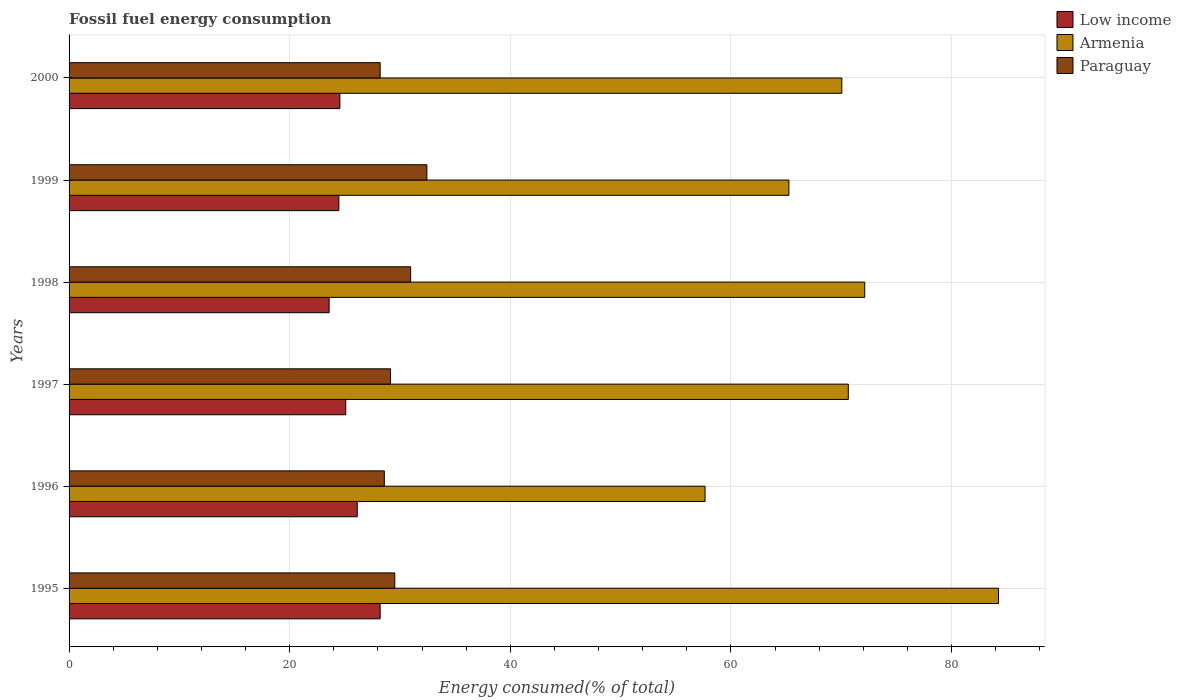How many different coloured bars are there?
Keep it short and to the point. 3. How many groups of bars are there?
Make the answer very short. 6. Are the number of bars per tick equal to the number of legend labels?
Offer a terse response. Yes. Are the number of bars on each tick of the Y-axis equal?
Make the answer very short. Yes. How many bars are there on the 1st tick from the top?
Your answer should be very brief. 3. What is the percentage of energy consumed in Low income in 1996?
Make the answer very short. 26.12. Across all years, what is the maximum percentage of energy consumed in Armenia?
Provide a succinct answer. 84.25. Across all years, what is the minimum percentage of energy consumed in Paraguay?
Your answer should be very brief. 28.2. In which year was the percentage of energy consumed in Low income maximum?
Give a very brief answer. 1995. What is the total percentage of energy consumed in Paraguay in the graph?
Provide a short and direct response. 178.84. What is the difference between the percentage of energy consumed in Armenia in 1995 and that in 2000?
Make the answer very short. 14.2. What is the difference between the percentage of energy consumed in Paraguay in 2000 and the percentage of energy consumed in Low income in 1997?
Give a very brief answer. 3.12. What is the average percentage of energy consumed in Paraguay per year?
Offer a terse response. 29.81. In the year 1999, what is the difference between the percentage of energy consumed in Low income and percentage of energy consumed in Paraguay?
Your answer should be compact. -7.98. In how many years, is the percentage of energy consumed in Low income greater than 4 %?
Provide a short and direct response. 6. What is the ratio of the percentage of energy consumed in Paraguay in 1998 to that in 2000?
Your answer should be very brief. 1.1. Is the difference between the percentage of energy consumed in Low income in 1995 and 2000 greater than the difference between the percentage of energy consumed in Paraguay in 1995 and 2000?
Ensure brevity in your answer.  Yes. What is the difference between the highest and the second highest percentage of energy consumed in Low income?
Your response must be concise. 2.08. What is the difference between the highest and the lowest percentage of energy consumed in Paraguay?
Your answer should be compact. 4.23. Is the sum of the percentage of energy consumed in Low income in 1996 and 1999 greater than the maximum percentage of energy consumed in Armenia across all years?
Provide a succinct answer. No. What does the 2nd bar from the bottom in 1996 represents?
Offer a terse response. Armenia. Is it the case that in every year, the sum of the percentage of energy consumed in Armenia and percentage of energy consumed in Low income is greater than the percentage of energy consumed in Paraguay?
Your answer should be very brief. Yes. Are all the bars in the graph horizontal?
Your answer should be very brief. Yes. What is the title of the graph?
Give a very brief answer. Fossil fuel energy consumption. Does "Poland" appear as one of the legend labels in the graph?
Offer a terse response. No. What is the label or title of the X-axis?
Make the answer very short. Energy consumed(% of total). What is the label or title of the Y-axis?
Provide a succinct answer. Years. What is the Energy consumed(% of total) in Low income in 1995?
Ensure brevity in your answer.  28.2. What is the Energy consumed(% of total) in Armenia in 1995?
Your answer should be very brief. 84.25. What is the Energy consumed(% of total) of Paraguay in 1995?
Give a very brief answer. 29.52. What is the Energy consumed(% of total) of Low income in 1996?
Keep it short and to the point. 26.12. What is the Energy consumed(% of total) of Armenia in 1996?
Offer a very short reply. 57.65. What is the Energy consumed(% of total) of Paraguay in 1996?
Keep it short and to the point. 28.58. What is the Energy consumed(% of total) of Low income in 1997?
Provide a short and direct response. 25.08. What is the Energy consumed(% of total) in Armenia in 1997?
Keep it short and to the point. 70.64. What is the Energy consumed(% of total) of Paraguay in 1997?
Your response must be concise. 29.14. What is the Energy consumed(% of total) of Low income in 1998?
Ensure brevity in your answer.  23.57. What is the Energy consumed(% of total) in Armenia in 1998?
Provide a short and direct response. 72.13. What is the Energy consumed(% of total) in Paraguay in 1998?
Ensure brevity in your answer.  30.96. What is the Energy consumed(% of total) of Low income in 1999?
Make the answer very short. 24.46. What is the Energy consumed(% of total) in Armenia in 1999?
Your response must be concise. 65.25. What is the Energy consumed(% of total) of Paraguay in 1999?
Your answer should be compact. 32.44. What is the Energy consumed(% of total) of Low income in 2000?
Provide a short and direct response. 24.55. What is the Energy consumed(% of total) in Armenia in 2000?
Offer a very short reply. 70.05. What is the Energy consumed(% of total) of Paraguay in 2000?
Give a very brief answer. 28.2. Across all years, what is the maximum Energy consumed(% of total) in Low income?
Your answer should be compact. 28.2. Across all years, what is the maximum Energy consumed(% of total) in Armenia?
Your response must be concise. 84.25. Across all years, what is the maximum Energy consumed(% of total) of Paraguay?
Offer a very short reply. 32.44. Across all years, what is the minimum Energy consumed(% of total) of Low income?
Your response must be concise. 23.57. Across all years, what is the minimum Energy consumed(% of total) in Armenia?
Provide a short and direct response. 57.65. Across all years, what is the minimum Energy consumed(% of total) in Paraguay?
Offer a terse response. 28.2. What is the total Energy consumed(% of total) in Low income in the graph?
Offer a very short reply. 151.98. What is the total Energy consumed(% of total) in Armenia in the graph?
Provide a succinct answer. 419.96. What is the total Energy consumed(% of total) of Paraguay in the graph?
Provide a short and direct response. 178.84. What is the difference between the Energy consumed(% of total) in Low income in 1995 and that in 1996?
Your answer should be very brief. 2.08. What is the difference between the Energy consumed(% of total) of Armenia in 1995 and that in 1996?
Your answer should be compact. 26.6. What is the difference between the Energy consumed(% of total) in Paraguay in 1995 and that in 1996?
Give a very brief answer. 0.95. What is the difference between the Energy consumed(% of total) in Low income in 1995 and that in 1997?
Offer a terse response. 3.12. What is the difference between the Energy consumed(% of total) of Armenia in 1995 and that in 1997?
Your response must be concise. 13.62. What is the difference between the Energy consumed(% of total) in Paraguay in 1995 and that in 1997?
Offer a very short reply. 0.39. What is the difference between the Energy consumed(% of total) in Low income in 1995 and that in 1998?
Offer a terse response. 4.63. What is the difference between the Energy consumed(% of total) in Armenia in 1995 and that in 1998?
Provide a short and direct response. 12.12. What is the difference between the Energy consumed(% of total) of Paraguay in 1995 and that in 1998?
Offer a very short reply. -1.44. What is the difference between the Energy consumed(% of total) in Low income in 1995 and that in 1999?
Provide a succinct answer. 3.74. What is the difference between the Energy consumed(% of total) in Armenia in 1995 and that in 1999?
Ensure brevity in your answer.  19. What is the difference between the Energy consumed(% of total) of Paraguay in 1995 and that in 1999?
Offer a very short reply. -2.91. What is the difference between the Energy consumed(% of total) in Low income in 1995 and that in 2000?
Keep it short and to the point. 3.65. What is the difference between the Energy consumed(% of total) in Armenia in 1995 and that in 2000?
Your answer should be very brief. 14.2. What is the difference between the Energy consumed(% of total) in Paraguay in 1995 and that in 2000?
Offer a terse response. 1.32. What is the difference between the Energy consumed(% of total) in Low income in 1996 and that in 1997?
Ensure brevity in your answer.  1.04. What is the difference between the Energy consumed(% of total) of Armenia in 1996 and that in 1997?
Offer a terse response. -12.99. What is the difference between the Energy consumed(% of total) of Paraguay in 1996 and that in 1997?
Your response must be concise. -0.56. What is the difference between the Energy consumed(% of total) of Low income in 1996 and that in 1998?
Provide a short and direct response. 2.55. What is the difference between the Energy consumed(% of total) in Armenia in 1996 and that in 1998?
Give a very brief answer. -14.48. What is the difference between the Energy consumed(% of total) of Paraguay in 1996 and that in 1998?
Give a very brief answer. -2.39. What is the difference between the Energy consumed(% of total) of Low income in 1996 and that in 1999?
Give a very brief answer. 1.67. What is the difference between the Energy consumed(% of total) of Armenia in 1996 and that in 1999?
Ensure brevity in your answer.  -7.6. What is the difference between the Energy consumed(% of total) of Paraguay in 1996 and that in 1999?
Provide a short and direct response. -3.86. What is the difference between the Energy consumed(% of total) of Low income in 1996 and that in 2000?
Provide a succinct answer. 1.57. What is the difference between the Energy consumed(% of total) of Armenia in 1996 and that in 2000?
Offer a very short reply. -12.4. What is the difference between the Energy consumed(% of total) in Paraguay in 1996 and that in 2000?
Offer a terse response. 0.38. What is the difference between the Energy consumed(% of total) of Low income in 1997 and that in 1998?
Keep it short and to the point. 1.51. What is the difference between the Energy consumed(% of total) of Armenia in 1997 and that in 1998?
Your response must be concise. -1.49. What is the difference between the Energy consumed(% of total) in Paraguay in 1997 and that in 1998?
Offer a terse response. -1.83. What is the difference between the Energy consumed(% of total) in Low income in 1997 and that in 1999?
Provide a succinct answer. 0.62. What is the difference between the Energy consumed(% of total) in Armenia in 1997 and that in 1999?
Offer a terse response. 5.38. What is the difference between the Energy consumed(% of total) in Paraguay in 1997 and that in 1999?
Ensure brevity in your answer.  -3.3. What is the difference between the Energy consumed(% of total) of Low income in 1997 and that in 2000?
Provide a succinct answer. 0.53. What is the difference between the Energy consumed(% of total) of Armenia in 1997 and that in 2000?
Your answer should be very brief. 0.59. What is the difference between the Energy consumed(% of total) of Paraguay in 1997 and that in 2000?
Offer a terse response. 0.94. What is the difference between the Energy consumed(% of total) in Low income in 1998 and that in 1999?
Ensure brevity in your answer.  -0.88. What is the difference between the Energy consumed(% of total) in Armenia in 1998 and that in 1999?
Your response must be concise. 6.87. What is the difference between the Energy consumed(% of total) in Paraguay in 1998 and that in 1999?
Your response must be concise. -1.47. What is the difference between the Energy consumed(% of total) in Low income in 1998 and that in 2000?
Ensure brevity in your answer.  -0.97. What is the difference between the Energy consumed(% of total) of Armenia in 1998 and that in 2000?
Provide a short and direct response. 2.08. What is the difference between the Energy consumed(% of total) of Paraguay in 1998 and that in 2000?
Your answer should be compact. 2.76. What is the difference between the Energy consumed(% of total) in Low income in 1999 and that in 2000?
Your response must be concise. -0.09. What is the difference between the Energy consumed(% of total) of Armenia in 1999 and that in 2000?
Offer a very short reply. -4.8. What is the difference between the Energy consumed(% of total) in Paraguay in 1999 and that in 2000?
Ensure brevity in your answer.  4.23. What is the difference between the Energy consumed(% of total) of Low income in 1995 and the Energy consumed(% of total) of Armenia in 1996?
Offer a very short reply. -29.45. What is the difference between the Energy consumed(% of total) in Low income in 1995 and the Energy consumed(% of total) in Paraguay in 1996?
Ensure brevity in your answer.  -0.38. What is the difference between the Energy consumed(% of total) in Armenia in 1995 and the Energy consumed(% of total) in Paraguay in 1996?
Offer a very short reply. 55.67. What is the difference between the Energy consumed(% of total) of Low income in 1995 and the Energy consumed(% of total) of Armenia in 1997?
Give a very brief answer. -42.44. What is the difference between the Energy consumed(% of total) in Low income in 1995 and the Energy consumed(% of total) in Paraguay in 1997?
Your response must be concise. -0.94. What is the difference between the Energy consumed(% of total) in Armenia in 1995 and the Energy consumed(% of total) in Paraguay in 1997?
Keep it short and to the point. 55.11. What is the difference between the Energy consumed(% of total) in Low income in 1995 and the Energy consumed(% of total) in Armenia in 1998?
Your answer should be very brief. -43.93. What is the difference between the Energy consumed(% of total) in Low income in 1995 and the Energy consumed(% of total) in Paraguay in 1998?
Offer a terse response. -2.76. What is the difference between the Energy consumed(% of total) in Armenia in 1995 and the Energy consumed(% of total) in Paraguay in 1998?
Provide a succinct answer. 53.29. What is the difference between the Energy consumed(% of total) of Low income in 1995 and the Energy consumed(% of total) of Armenia in 1999?
Offer a very short reply. -37.05. What is the difference between the Energy consumed(% of total) in Low income in 1995 and the Energy consumed(% of total) in Paraguay in 1999?
Your answer should be very brief. -4.24. What is the difference between the Energy consumed(% of total) of Armenia in 1995 and the Energy consumed(% of total) of Paraguay in 1999?
Your response must be concise. 51.82. What is the difference between the Energy consumed(% of total) of Low income in 1995 and the Energy consumed(% of total) of Armenia in 2000?
Ensure brevity in your answer.  -41.85. What is the difference between the Energy consumed(% of total) in Low income in 1995 and the Energy consumed(% of total) in Paraguay in 2000?
Provide a succinct answer. -0. What is the difference between the Energy consumed(% of total) in Armenia in 1995 and the Energy consumed(% of total) in Paraguay in 2000?
Your answer should be compact. 56.05. What is the difference between the Energy consumed(% of total) in Low income in 1996 and the Energy consumed(% of total) in Armenia in 1997?
Give a very brief answer. -44.51. What is the difference between the Energy consumed(% of total) in Low income in 1996 and the Energy consumed(% of total) in Paraguay in 1997?
Your answer should be compact. -3.02. What is the difference between the Energy consumed(% of total) of Armenia in 1996 and the Energy consumed(% of total) of Paraguay in 1997?
Offer a terse response. 28.51. What is the difference between the Energy consumed(% of total) of Low income in 1996 and the Energy consumed(% of total) of Armenia in 1998?
Offer a very short reply. -46. What is the difference between the Energy consumed(% of total) of Low income in 1996 and the Energy consumed(% of total) of Paraguay in 1998?
Provide a short and direct response. -4.84. What is the difference between the Energy consumed(% of total) in Armenia in 1996 and the Energy consumed(% of total) in Paraguay in 1998?
Your answer should be very brief. 26.69. What is the difference between the Energy consumed(% of total) in Low income in 1996 and the Energy consumed(% of total) in Armenia in 1999?
Your answer should be compact. -39.13. What is the difference between the Energy consumed(% of total) of Low income in 1996 and the Energy consumed(% of total) of Paraguay in 1999?
Ensure brevity in your answer.  -6.31. What is the difference between the Energy consumed(% of total) in Armenia in 1996 and the Energy consumed(% of total) in Paraguay in 1999?
Provide a short and direct response. 25.22. What is the difference between the Energy consumed(% of total) in Low income in 1996 and the Energy consumed(% of total) in Armenia in 2000?
Your response must be concise. -43.93. What is the difference between the Energy consumed(% of total) in Low income in 1996 and the Energy consumed(% of total) in Paraguay in 2000?
Your answer should be compact. -2.08. What is the difference between the Energy consumed(% of total) of Armenia in 1996 and the Energy consumed(% of total) of Paraguay in 2000?
Offer a terse response. 29.45. What is the difference between the Energy consumed(% of total) of Low income in 1997 and the Energy consumed(% of total) of Armenia in 1998?
Offer a very short reply. -47.05. What is the difference between the Energy consumed(% of total) in Low income in 1997 and the Energy consumed(% of total) in Paraguay in 1998?
Make the answer very short. -5.88. What is the difference between the Energy consumed(% of total) of Armenia in 1997 and the Energy consumed(% of total) of Paraguay in 1998?
Provide a short and direct response. 39.67. What is the difference between the Energy consumed(% of total) of Low income in 1997 and the Energy consumed(% of total) of Armenia in 1999?
Your answer should be compact. -40.17. What is the difference between the Energy consumed(% of total) in Low income in 1997 and the Energy consumed(% of total) in Paraguay in 1999?
Give a very brief answer. -7.36. What is the difference between the Energy consumed(% of total) in Armenia in 1997 and the Energy consumed(% of total) in Paraguay in 1999?
Your answer should be very brief. 38.2. What is the difference between the Energy consumed(% of total) in Low income in 1997 and the Energy consumed(% of total) in Armenia in 2000?
Your response must be concise. -44.97. What is the difference between the Energy consumed(% of total) of Low income in 1997 and the Energy consumed(% of total) of Paraguay in 2000?
Give a very brief answer. -3.12. What is the difference between the Energy consumed(% of total) in Armenia in 1997 and the Energy consumed(% of total) in Paraguay in 2000?
Offer a very short reply. 42.44. What is the difference between the Energy consumed(% of total) of Low income in 1998 and the Energy consumed(% of total) of Armenia in 1999?
Offer a terse response. -41.68. What is the difference between the Energy consumed(% of total) of Low income in 1998 and the Energy consumed(% of total) of Paraguay in 1999?
Keep it short and to the point. -8.86. What is the difference between the Energy consumed(% of total) of Armenia in 1998 and the Energy consumed(% of total) of Paraguay in 1999?
Offer a terse response. 39.69. What is the difference between the Energy consumed(% of total) of Low income in 1998 and the Energy consumed(% of total) of Armenia in 2000?
Offer a terse response. -46.48. What is the difference between the Energy consumed(% of total) in Low income in 1998 and the Energy consumed(% of total) in Paraguay in 2000?
Your answer should be very brief. -4.63. What is the difference between the Energy consumed(% of total) in Armenia in 1998 and the Energy consumed(% of total) in Paraguay in 2000?
Offer a terse response. 43.93. What is the difference between the Energy consumed(% of total) of Low income in 1999 and the Energy consumed(% of total) of Armenia in 2000?
Ensure brevity in your answer.  -45.59. What is the difference between the Energy consumed(% of total) in Low income in 1999 and the Energy consumed(% of total) in Paraguay in 2000?
Make the answer very short. -3.74. What is the difference between the Energy consumed(% of total) of Armenia in 1999 and the Energy consumed(% of total) of Paraguay in 2000?
Provide a short and direct response. 37.05. What is the average Energy consumed(% of total) in Low income per year?
Ensure brevity in your answer.  25.33. What is the average Energy consumed(% of total) of Armenia per year?
Keep it short and to the point. 69.99. What is the average Energy consumed(% of total) in Paraguay per year?
Your answer should be very brief. 29.81. In the year 1995, what is the difference between the Energy consumed(% of total) of Low income and Energy consumed(% of total) of Armenia?
Ensure brevity in your answer.  -56.05. In the year 1995, what is the difference between the Energy consumed(% of total) of Low income and Energy consumed(% of total) of Paraguay?
Offer a very short reply. -1.32. In the year 1995, what is the difference between the Energy consumed(% of total) of Armenia and Energy consumed(% of total) of Paraguay?
Make the answer very short. 54.73. In the year 1996, what is the difference between the Energy consumed(% of total) in Low income and Energy consumed(% of total) in Armenia?
Your answer should be very brief. -31.53. In the year 1996, what is the difference between the Energy consumed(% of total) of Low income and Energy consumed(% of total) of Paraguay?
Provide a succinct answer. -2.46. In the year 1996, what is the difference between the Energy consumed(% of total) in Armenia and Energy consumed(% of total) in Paraguay?
Your response must be concise. 29.07. In the year 1997, what is the difference between the Energy consumed(% of total) of Low income and Energy consumed(% of total) of Armenia?
Your answer should be compact. -45.56. In the year 1997, what is the difference between the Energy consumed(% of total) in Low income and Energy consumed(% of total) in Paraguay?
Ensure brevity in your answer.  -4.06. In the year 1997, what is the difference between the Energy consumed(% of total) in Armenia and Energy consumed(% of total) in Paraguay?
Ensure brevity in your answer.  41.5. In the year 1998, what is the difference between the Energy consumed(% of total) of Low income and Energy consumed(% of total) of Armenia?
Ensure brevity in your answer.  -48.55. In the year 1998, what is the difference between the Energy consumed(% of total) of Low income and Energy consumed(% of total) of Paraguay?
Give a very brief answer. -7.39. In the year 1998, what is the difference between the Energy consumed(% of total) of Armenia and Energy consumed(% of total) of Paraguay?
Give a very brief answer. 41.16. In the year 1999, what is the difference between the Energy consumed(% of total) in Low income and Energy consumed(% of total) in Armenia?
Provide a succinct answer. -40.8. In the year 1999, what is the difference between the Energy consumed(% of total) of Low income and Energy consumed(% of total) of Paraguay?
Provide a short and direct response. -7.98. In the year 1999, what is the difference between the Energy consumed(% of total) in Armenia and Energy consumed(% of total) in Paraguay?
Provide a short and direct response. 32.82. In the year 2000, what is the difference between the Energy consumed(% of total) in Low income and Energy consumed(% of total) in Armenia?
Make the answer very short. -45.5. In the year 2000, what is the difference between the Energy consumed(% of total) in Low income and Energy consumed(% of total) in Paraguay?
Keep it short and to the point. -3.65. In the year 2000, what is the difference between the Energy consumed(% of total) in Armenia and Energy consumed(% of total) in Paraguay?
Keep it short and to the point. 41.85. What is the ratio of the Energy consumed(% of total) of Low income in 1995 to that in 1996?
Offer a terse response. 1.08. What is the ratio of the Energy consumed(% of total) of Armenia in 1995 to that in 1996?
Provide a succinct answer. 1.46. What is the ratio of the Energy consumed(% of total) in Paraguay in 1995 to that in 1996?
Provide a short and direct response. 1.03. What is the ratio of the Energy consumed(% of total) in Low income in 1995 to that in 1997?
Keep it short and to the point. 1.12. What is the ratio of the Energy consumed(% of total) of Armenia in 1995 to that in 1997?
Provide a succinct answer. 1.19. What is the ratio of the Energy consumed(% of total) in Paraguay in 1995 to that in 1997?
Provide a succinct answer. 1.01. What is the ratio of the Energy consumed(% of total) of Low income in 1995 to that in 1998?
Your answer should be compact. 1.2. What is the ratio of the Energy consumed(% of total) of Armenia in 1995 to that in 1998?
Give a very brief answer. 1.17. What is the ratio of the Energy consumed(% of total) in Paraguay in 1995 to that in 1998?
Provide a short and direct response. 0.95. What is the ratio of the Energy consumed(% of total) in Low income in 1995 to that in 1999?
Your response must be concise. 1.15. What is the ratio of the Energy consumed(% of total) of Armenia in 1995 to that in 1999?
Offer a terse response. 1.29. What is the ratio of the Energy consumed(% of total) of Paraguay in 1995 to that in 1999?
Offer a very short reply. 0.91. What is the ratio of the Energy consumed(% of total) in Low income in 1995 to that in 2000?
Your answer should be compact. 1.15. What is the ratio of the Energy consumed(% of total) of Armenia in 1995 to that in 2000?
Provide a short and direct response. 1.2. What is the ratio of the Energy consumed(% of total) of Paraguay in 1995 to that in 2000?
Provide a short and direct response. 1.05. What is the ratio of the Energy consumed(% of total) of Low income in 1996 to that in 1997?
Give a very brief answer. 1.04. What is the ratio of the Energy consumed(% of total) of Armenia in 1996 to that in 1997?
Offer a very short reply. 0.82. What is the ratio of the Energy consumed(% of total) of Paraguay in 1996 to that in 1997?
Your response must be concise. 0.98. What is the ratio of the Energy consumed(% of total) of Low income in 1996 to that in 1998?
Your answer should be compact. 1.11. What is the ratio of the Energy consumed(% of total) of Armenia in 1996 to that in 1998?
Provide a short and direct response. 0.8. What is the ratio of the Energy consumed(% of total) of Paraguay in 1996 to that in 1998?
Make the answer very short. 0.92. What is the ratio of the Energy consumed(% of total) of Low income in 1996 to that in 1999?
Make the answer very short. 1.07. What is the ratio of the Energy consumed(% of total) of Armenia in 1996 to that in 1999?
Provide a short and direct response. 0.88. What is the ratio of the Energy consumed(% of total) of Paraguay in 1996 to that in 1999?
Your answer should be very brief. 0.88. What is the ratio of the Energy consumed(% of total) of Low income in 1996 to that in 2000?
Your answer should be very brief. 1.06. What is the ratio of the Energy consumed(% of total) in Armenia in 1996 to that in 2000?
Offer a terse response. 0.82. What is the ratio of the Energy consumed(% of total) in Paraguay in 1996 to that in 2000?
Give a very brief answer. 1.01. What is the ratio of the Energy consumed(% of total) in Low income in 1997 to that in 1998?
Ensure brevity in your answer.  1.06. What is the ratio of the Energy consumed(% of total) in Armenia in 1997 to that in 1998?
Your answer should be very brief. 0.98. What is the ratio of the Energy consumed(% of total) in Paraguay in 1997 to that in 1998?
Offer a terse response. 0.94. What is the ratio of the Energy consumed(% of total) of Low income in 1997 to that in 1999?
Provide a succinct answer. 1.03. What is the ratio of the Energy consumed(% of total) in Armenia in 1997 to that in 1999?
Give a very brief answer. 1.08. What is the ratio of the Energy consumed(% of total) in Paraguay in 1997 to that in 1999?
Provide a succinct answer. 0.9. What is the ratio of the Energy consumed(% of total) in Low income in 1997 to that in 2000?
Your response must be concise. 1.02. What is the ratio of the Energy consumed(% of total) in Armenia in 1997 to that in 2000?
Make the answer very short. 1.01. What is the ratio of the Energy consumed(% of total) in Paraguay in 1997 to that in 2000?
Provide a succinct answer. 1.03. What is the ratio of the Energy consumed(% of total) in Low income in 1998 to that in 1999?
Offer a terse response. 0.96. What is the ratio of the Energy consumed(% of total) of Armenia in 1998 to that in 1999?
Ensure brevity in your answer.  1.11. What is the ratio of the Energy consumed(% of total) in Paraguay in 1998 to that in 1999?
Your answer should be compact. 0.95. What is the ratio of the Energy consumed(% of total) in Low income in 1998 to that in 2000?
Offer a very short reply. 0.96. What is the ratio of the Energy consumed(% of total) in Armenia in 1998 to that in 2000?
Provide a short and direct response. 1.03. What is the ratio of the Energy consumed(% of total) in Paraguay in 1998 to that in 2000?
Your answer should be very brief. 1.1. What is the ratio of the Energy consumed(% of total) of Armenia in 1999 to that in 2000?
Give a very brief answer. 0.93. What is the ratio of the Energy consumed(% of total) in Paraguay in 1999 to that in 2000?
Give a very brief answer. 1.15. What is the difference between the highest and the second highest Energy consumed(% of total) in Low income?
Your answer should be very brief. 2.08. What is the difference between the highest and the second highest Energy consumed(% of total) in Armenia?
Ensure brevity in your answer.  12.12. What is the difference between the highest and the second highest Energy consumed(% of total) of Paraguay?
Give a very brief answer. 1.47. What is the difference between the highest and the lowest Energy consumed(% of total) in Low income?
Make the answer very short. 4.63. What is the difference between the highest and the lowest Energy consumed(% of total) in Armenia?
Give a very brief answer. 26.6. What is the difference between the highest and the lowest Energy consumed(% of total) in Paraguay?
Offer a terse response. 4.23. 